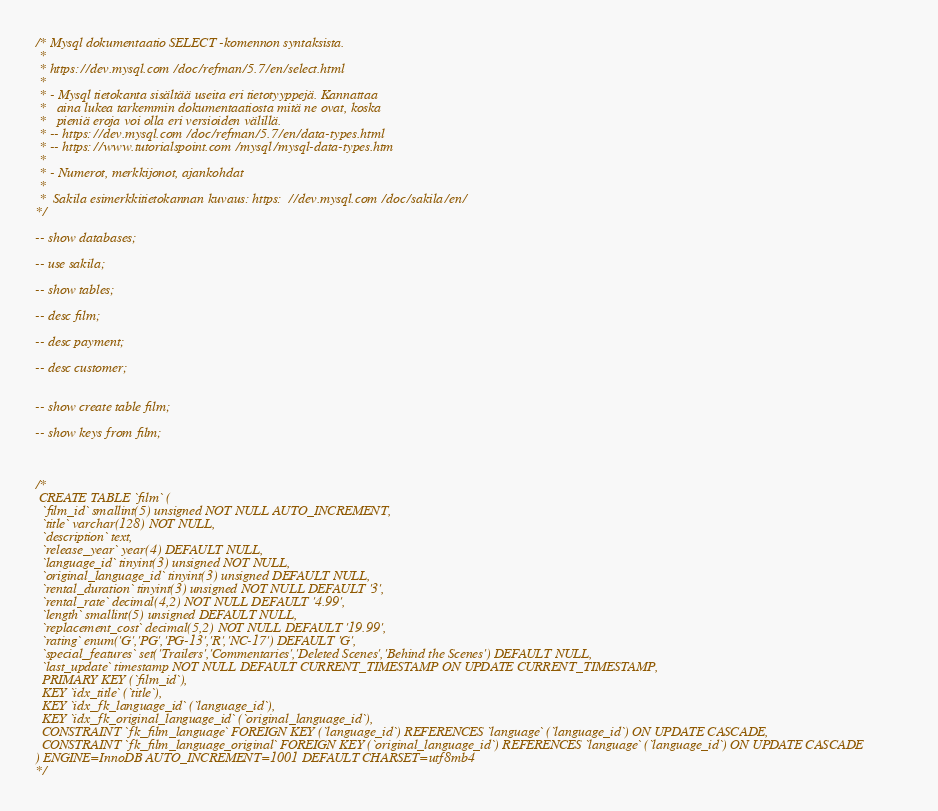Convert code to text. <code><loc_0><loc_0><loc_500><loc_500><_SQL_>
/* Mysql dokumentaatio SELECT -komennon syntaksista.
 * 
 * https://dev.mysql.com/doc/refman/5.7/en/select.html
 * 
 * - Mysql tietokanta sisältää useita eri tietotyyppejä. Kannattaa
 *   aina lukea tarkemmin dokumentaatiosta mitä ne ovat, koska
 *   pieniä eroja voi olla eri versioiden välillä.
 * -- https://dev.mysql.com/doc/refman/5.7/en/data-types.html
 * -- https://www.tutorialspoint.com/mysql/mysql-data-types.htm
 * 
 * - Numerot, merkkijonot, ajankohdat
 * 
 *  Sakila esimerkkitietokannan kuvaus: https://dev.mysql.com/doc/sakila/en/
*/ 

-- show databases;

-- use sakila;

-- show tables;

-- desc film;

-- desc payment;

-- desc customer;


-- show create table film;

-- show keys from film;



/* 
 CREATE TABLE `film` (
  `film_id` smallint(5) unsigned NOT NULL AUTO_INCREMENT,
  `title` varchar(128) NOT NULL,
  `description` text,
  `release_year` year(4) DEFAULT NULL,
  `language_id` tinyint(3) unsigned NOT NULL,
  `original_language_id` tinyint(3) unsigned DEFAULT NULL,
  `rental_duration` tinyint(3) unsigned NOT NULL DEFAULT '3',
  `rental_rate` decimal(4,2) NOT NULL DEFAULT '4.99',
  `length` smallint(5) unsigned DEFAULT NULL,
  `replacement_cost` decimal(5,2) NOT NULL DEFAULT '19.99',
  `rating` enum('G','PG','PG-13','R','NC-17') DEFAULT 'G',
  `special_features` set('Trailers','Commentaries','Deleted Scenes','Behind the Scenes') DEFAULT NULL,
  `last_update` timestamp NOT NULL DEFAULT CURRENT_TIMESTAMP ON UPDATE CURRENT_TIMESTAMP,
  PRIMARY KEY (`film_id`),
  KEY `idx_title` (`title`),
  KEY `idx_fk_language_id` (`language_id`),
  KEY `idx_fk_original_language_id` (`original_language_id`),
  CONSTRAINT `fk_film_language` FOREIGN KEY (`language_id`) REFERENCES `language` (`language_id`) ON UPDATE CASCADE,
  CONSTRAINT `fk_film_language_original` FOREIGN KEY (`original_language_id`) REFERENCES `language` (`language_id`) ON UPDATE CASCADE
) ENGINE=InnoDB AUTO_INCREMENT=1001 DEFAULT CHARSET=utf8mb4
*/

</code> 